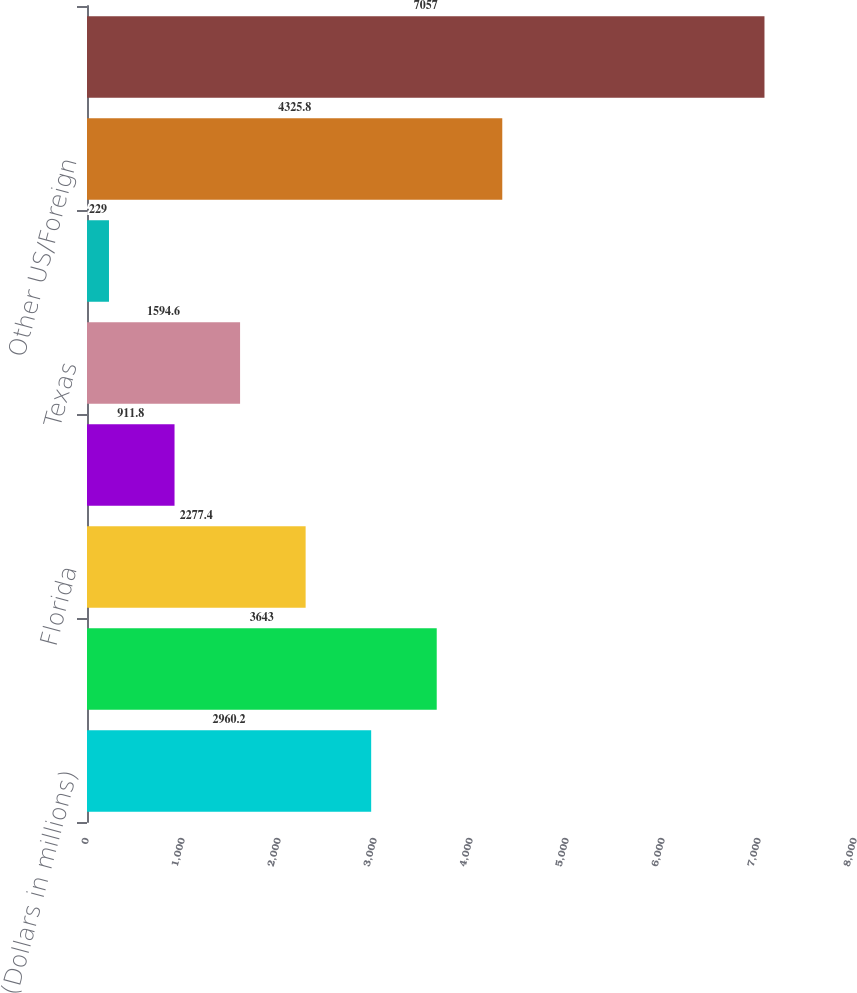Convert chart to OTSL. <chart><loc_0><loc_0><loc_500><loc_500><bar_chart><fcel>(Dollars in millions)<fcel>California<fcel>Florida<fcel>New York<fcel>Texas<fcel>Virginia<fcel>Other US/Foreign<fcel>Total residential mortgage<nl><fcel>2960.2<fcel>3643<fcel>2277.4<fcel>911.8<fcel>1594.6<fcel>229<fcel>4325.8<fcel>7057<nl></chart> 